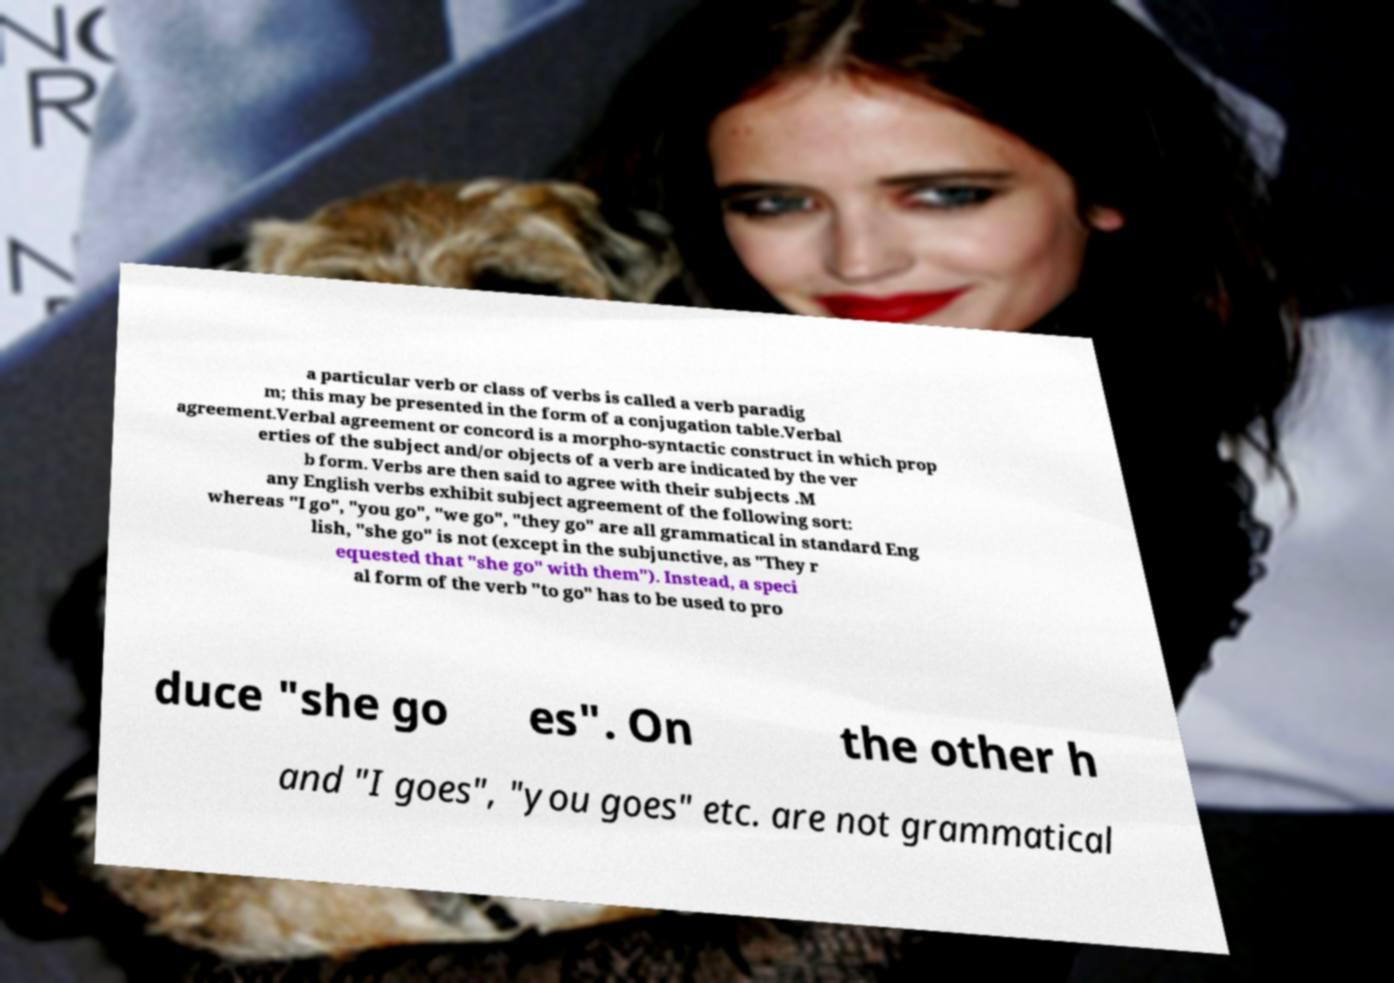Could you assist in decoding the text presented in this image and type it out clearly? a particular verb or class of verbs is called a verb paradig m; this may be presented in the form of a conjugation table.Verbal agreement.Verbal agreement or concord is a morpho-syntactic construct in which prop erties of the subject and/or objects of a verb are indicated by the ver b form. Verbs are then said to agree with their subjects .M any English verbs exhibit subject agreement of the following sort: whereas "I go", "you go", "we go", "they go" are all grammatical in standard Eng lish, "she go" is not (except in the subjunctive, as "They r equested that "she go" with them"). Instead, a speci al form of the verb "to go" has to be used to pro duce "she go es". On the other h and "I goes", "you goes" etc. are not grammatical 